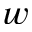Convert formula to latex. <formula><loc_0><loc_0><loc_500><loc_500>w</formula> 